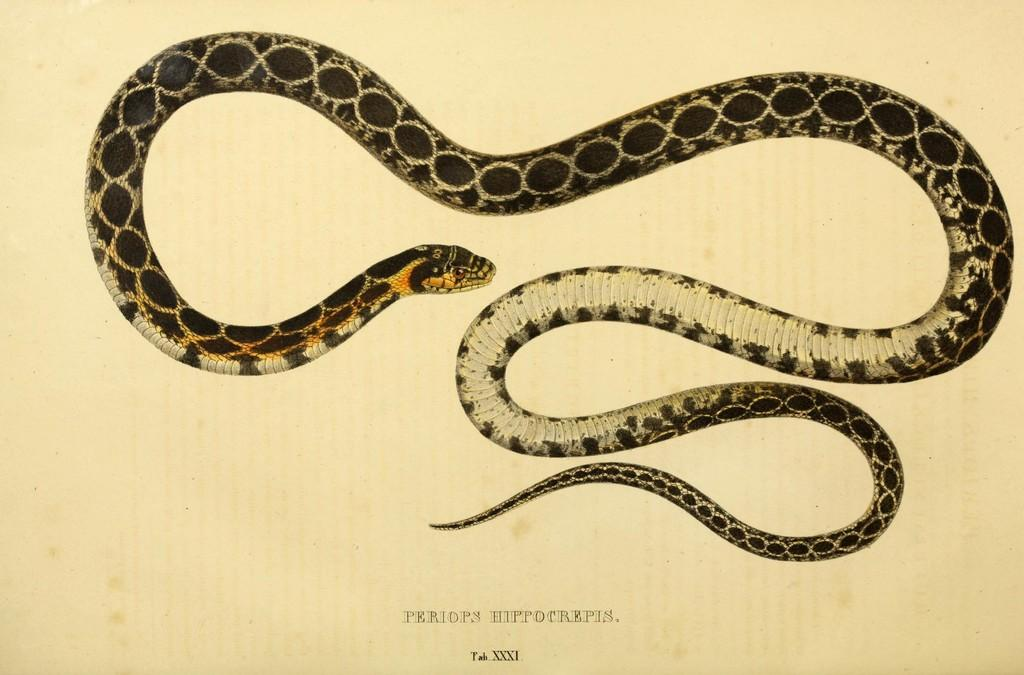What is the main subject of the image? The main subject of the image is a picture of a snake. What else can be seen in the image besides the snake? There are letters on a paper in the image. What type of fear can be seen on the face of the yam in the image? There is no yam present in the image, and therefore no facial expression to analyze. What question is being asked by the snake in the image? There is no indication in the image that the snake is asking a question or capable of asking a question. 